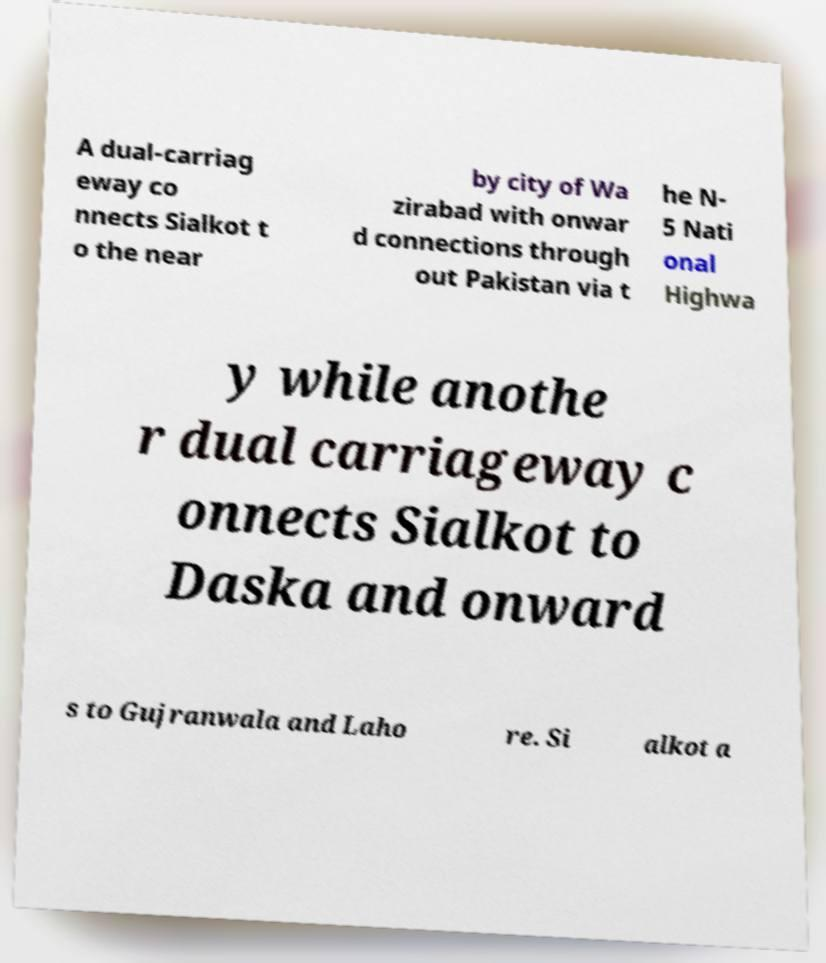Could you assist in decoding the text presented in this image and type it out clearly? A dual-carriag eway co nnects Sialkot t o the near by city of Wa zirabad with onwar d connections through out Pakistan via t he N- 5 Nati onal Highwa y while anothe r dual carriageway c onnects Sialkot to Daska and onward s to Gujranwala and Laho re. Si alkot a 